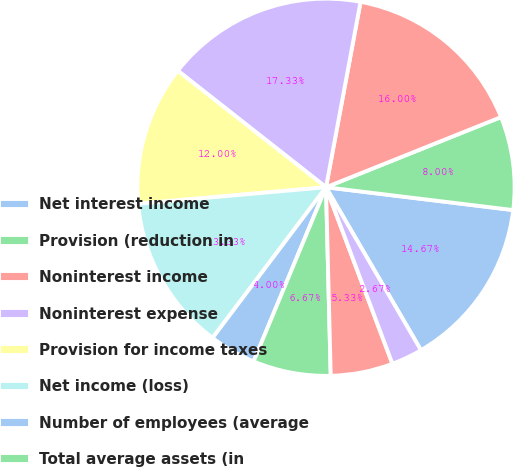<chart> <loc_0><loc_0><loc_500><loc_500><pie_chart><fcel>Net interest income<fcel>Provision (reduction in<fcel>Noninterest income<fcel>Noninterest expense<fcel>Provision for income taxes<fcel>Net income (loss)<fcel>Number of employees (average<fcel>Total average assets (in<fcel>Total average loans/leases (in<fcel>Total average deposits (in<nl><fcel>14.67%<fcel>8.0%<fcel>16.0%<fcel>17.33%<fcel>12.0%<fcel>13.33%<fcel>4.0%<fcel>6.67%<fcel>5.33%<fcel>2.67%<nl></chart> 